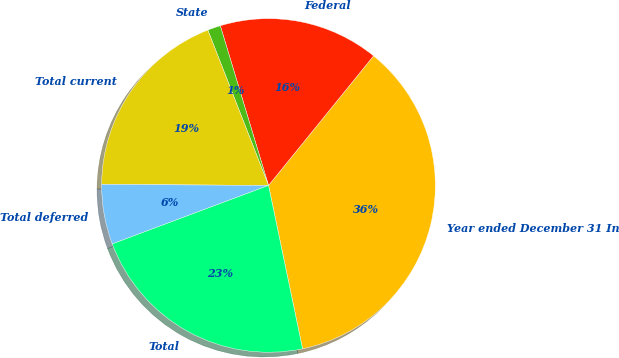Convert chart. <chart><loc_0><loc_0><loc_500><loc_500><pie_chart><fcel>Year ended December 31 In<fcel>Federal<fcel>State<fcel>Total current<fcel>Total deferred<fcel>Total<nl><fcel>35.89%<fcel>15.51%<fcel>1.26%<fcel>18.97%<fcel>5.8%<fcel>22.57%<nl></chart> 